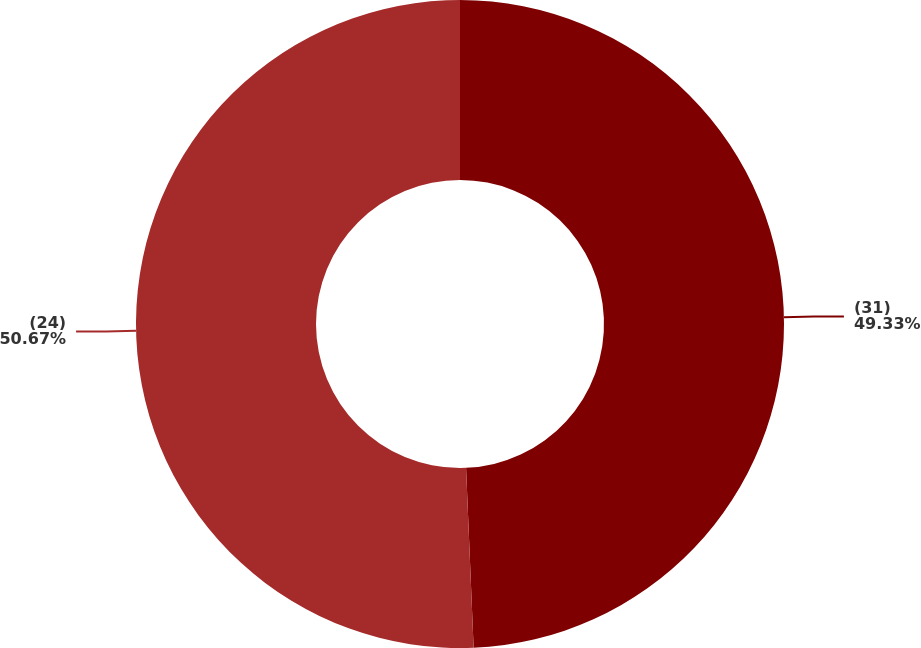<chart> <loc_0><loc_0><loc_500><loc_500><pie_chart><fcel>(31)<fcel>(24)<nl><fcel>49.33%<fcel>50.67%<nl></chart> 